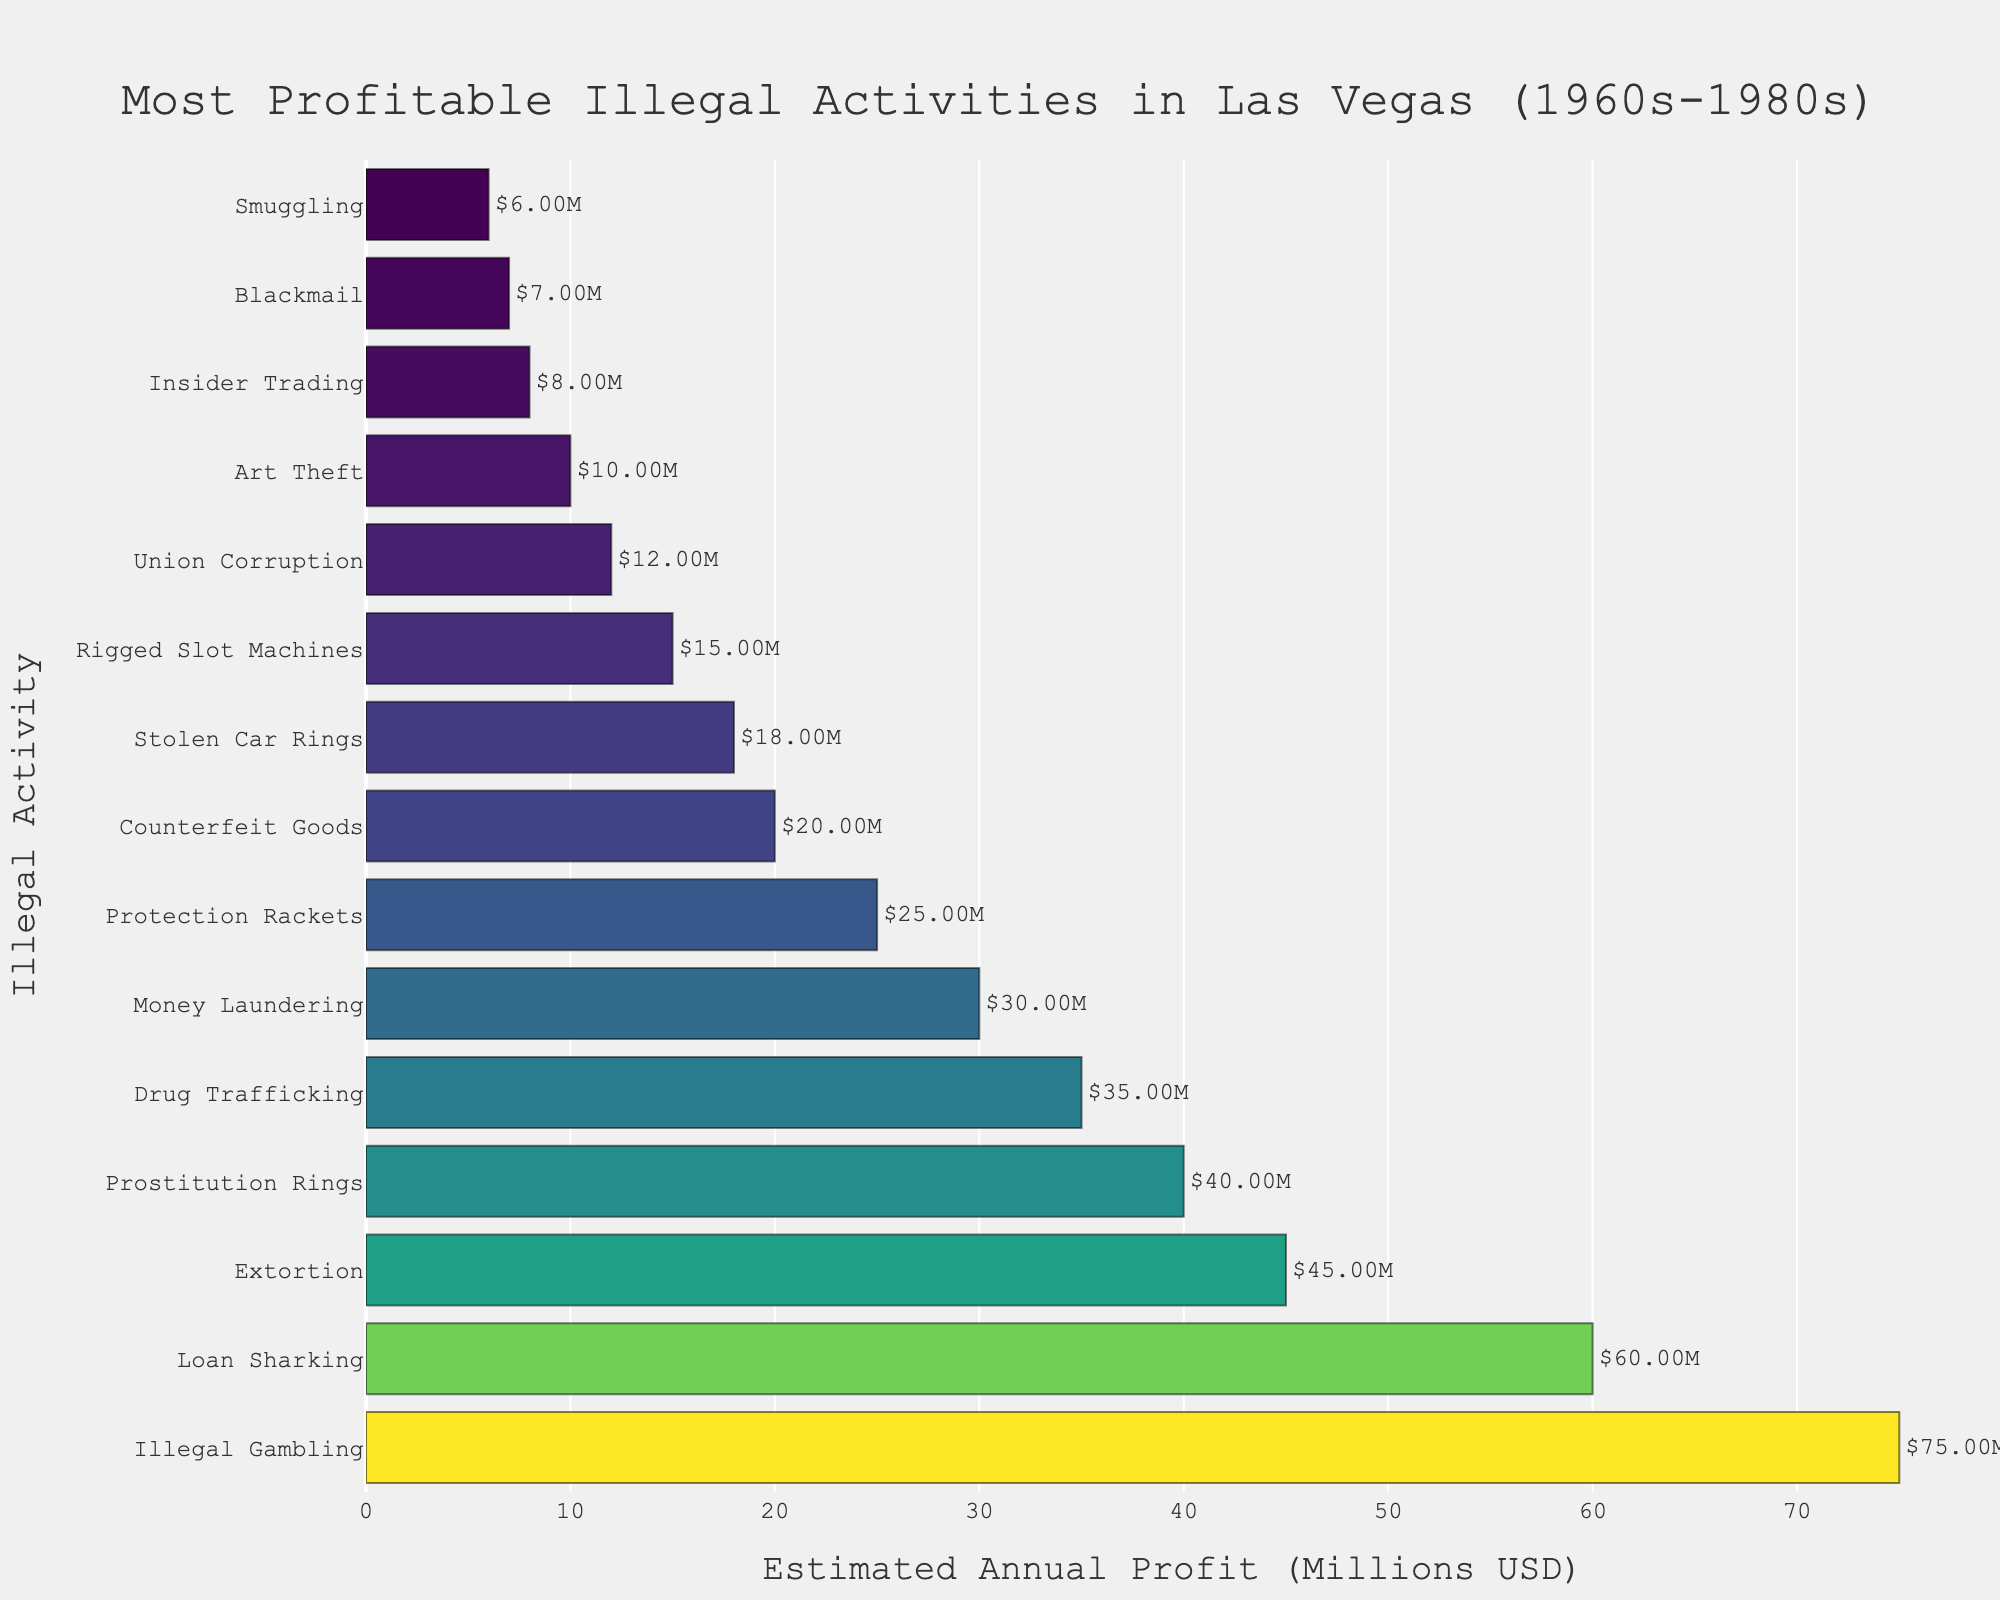Which illegal activity was the most profitable in Las Vegas during the 1960s-1980s? The figure shows the bar chart with "Illegal Gambling" at the top, indicating it had the highest estimated annual profit.
Answer: Illegal Gambling How much more profitable was Illegal Gambling compared to Drug Trafficking? From the chart, Illegal Gambling had an estimated annual profit of 75 million USD, whereas Drug Trafficking had 35 million USD. The difference is 75 - 35 = 40 million USD.
Answer: 40 million USD What are the total estimated annual profits for Prostitution Rings and Money Laundering? The figure shows Prostitution Rings with an estimated profit of 40 million USD and Money Laundering with 30 million USD. The total is 40 + 30 = 70 million USD.
Answer: 70 million USD Which activity showed more profit: Extortion or Protection Rackets? According to the figure, Extortion had an estimated annual profit of 45 million USD, and Protection Rackets had 25 million USD. Extortion was more profitable.
Answer: Extortion What is the average estimated annual profit of the top three most profitable activities? The top three activities are Illegal Gambling (75 million USD), Loan Sharking (60 million USD), and Extortion (45 million USD). The sum is 75 + 60 + 45 = 180 million USD, and the average is 180 / 3 = 60 million USD.
Answer: 60 million USD How much less profitable was Union Corruption compared to Loan Sharking? The chart shows that Loan Sharking had an estimated annual profit of 60 million USD, and Union Corruption had 12 million USD. The difference is 60 - 12 = 48 million USD.
Answer: 48 million USD Rank the following activities in order of profitability: Blackmail, Stolen Car Rings, and Smuggling. Based on the bar lengths and corresponding values from the chart: Stolen Car Rings (18 million USD), Blackmail (7 million USD), and Smuggling (6 million USD).
Answer: Stolen Car Rings, Blackmail, Smuggling Which illegal activity had an estimated annual profit closest to 20 million USD? The figure shows "Counterfeit Goods" with an estimated annual profit of 20 million USD.
Answer: Counterfeit Goods What is the combined estimated annual profit of the least profitable five activities on the chart? The five least profitable activities are Insider Trading (8 million USD), Blackmail (7 million USD), Smuggling (6 million USD). The sum is 8 + 7 + 6 = 21 million USD.
Answer: 21 million USD 